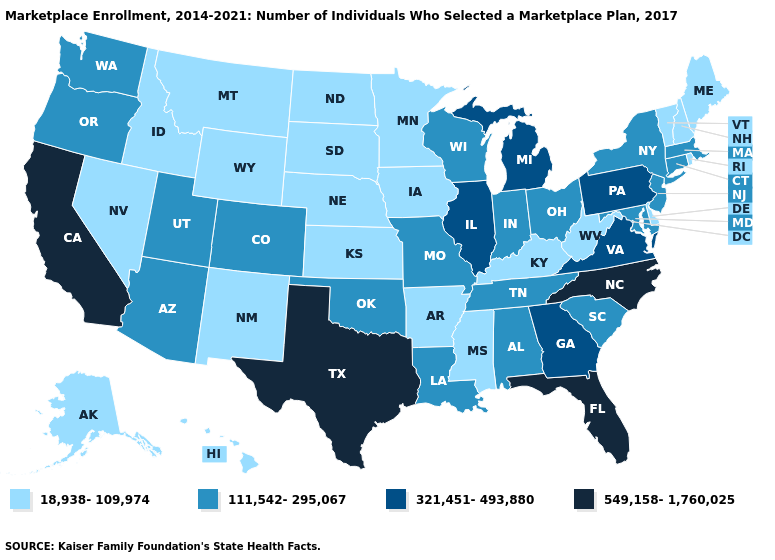Does California have the highest value in the USA?
Be succinct. Yes. What is the value of Alabama?
Short answer required. 111,542-295,067. Which states hav the highest value in the Northeast?
Give a very brief answer. Pennsylvania. What is the value of Iowa?
Give a very brief answer. 18,938-109,974. Which states have the lowest value in the MidWest?
Quick response, please. Iowa, Kansas, Minnesota, Nebraska, North Dakota, South Dakota. Does Rhode Island have the highest value in the Northeast?
Concise answer only. No. Name the states that have a value in the range 549,158-1,760,025?
Keep it brief. California, Florida, North Carolina, Texas. What is the lowest value in the USA?
Keep it brief. 18,938-109,974. Name the states that have a value in the range 549,158-1,760,025?
Give a very brief answer. California, Florida, North Carolina, Texas. Which states have the lowest value in the USA?
Give a very brief answer. Alaska, Arkansas, Delaware, Hawaii, Idaho, Iowa, Kansas, Kentucky, Maine, Minnesota, Mississippi, Montana, Nebraska, Nevada, New Hampshire, New Mexico, North Dakota, Rhode Island, South Dakota, Vermont, West Virginia, Wyoming. Name the states that have a value in the range 111,542-295,067?
Short answer required. Alabama, Arizona, Colorado, Connecticut, Indiana, Louisiana, Maryland, Massachusetts, Missouri, New Jersey, New York, Ohio, Oklahoma, Oregon, South Carolina, Tennessee, Utah, Washington, Wisconsin. What is the value of Maryland?
Quick response, please. 111,542-295,067. Which states have the highest value in the USA?
Concise answer only. California, Florida, North Carolina, Texas. What is the highest value in states that border Minnesota?
Write a very short answer. 111,542-295,067. 